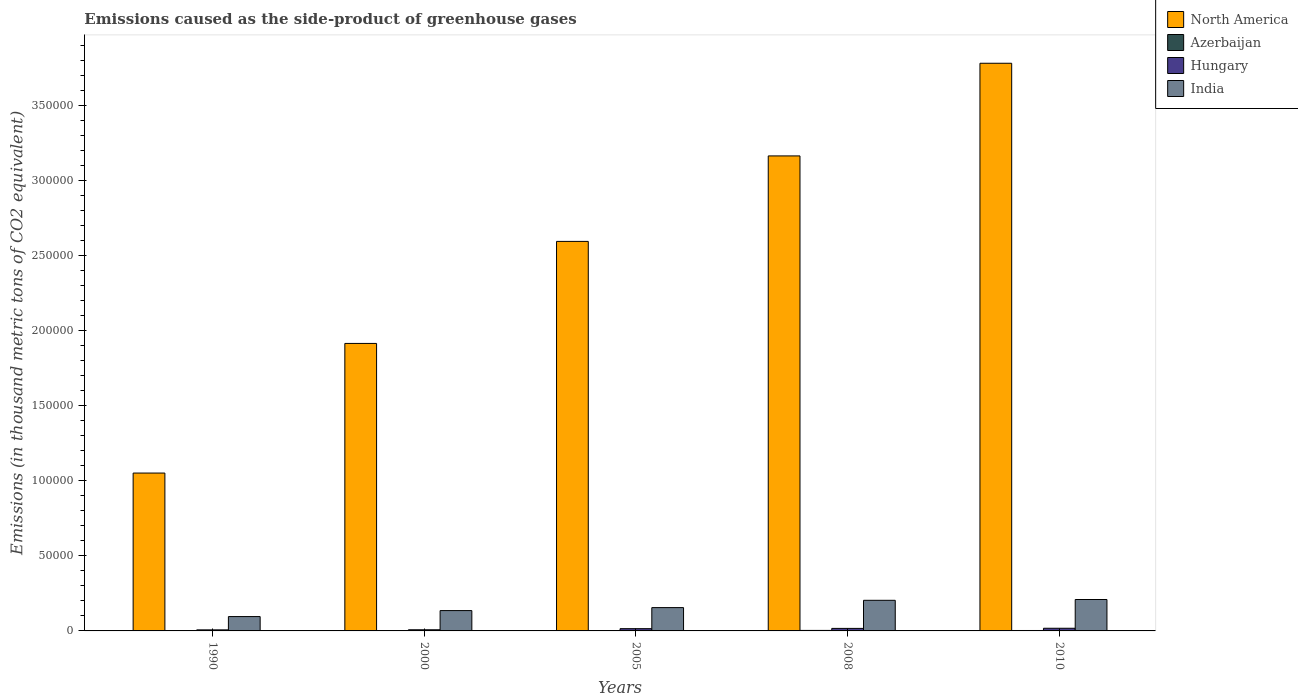How many different coloured bars are there?
Provide a succinct answer. 4. How many bars are there on the 4th tick from the right?
Your answer should be very brief. 4. What is the label of the 4th group of bars from the left?
Provide a succinct answer. 2008. What is the emissions caused as the side-product of greenhouse gases in India in 1990?
Make the answer very short. 9563.6. Across all years, what is the maximum emissions caused as the side-product of greenhouse gases in Hungary?
Offer a terse response. 1778. Across all years, what is the minimum emissions caused as the side-product of greenhouse gases in North America?
Keep it short and to the point. 1.05e+05. What is the total emissions caused as the side-product of greenhouse gases in Hungary in the graph?
Make the answer very short. 6431.5. What is the difference between the emissions caused as the side-product of greenhouse gases in Hungary in 2000 and that in 2005?
Your answer should be compact. -743.2. What is the difference between the emissions caused as the side-product of greenhouse gases in Azerbaijan in 2008 and the emissions caused as the side-product of greenhouse gases in Hungary in 2010?
Your answer should be very brief. -1442.7. What is the average emissions caused as the side-product of greenhouse gases in Hungary per year?
Provide a succinct answer. 1286.3. In the year 2005, what is the difference between the emissions caused as the side-product of greenhouse gases in Azerbaijan and emissions caused as the side-product of greenhouse gases in Hungary?
Provide a succinct answer. -1240. What is the ratio of the emissions caused as the side-product of greenhouse gases in North America in 2005 to that in 2008?
Ensure brevity in your answer.  0.82. What is the difference between the highest and the second highest emissions caused as the side-product of greenhouse gases in Azerbaijan?
Ensure brevity in your answer.  52.3. What is the difference between the highest and the lowest emissions caused as the side-product of greenhouse gases in Hungary?
Offer a terse response. 1076. Is the sum of the emissions caused as the side-product of greenhouse gases in North America in 1990 and 2008 greater than the maximum emissions caused as the side-product of greenhouse gases in Hungary across all years?
Give a very brief answer. Yes. Is it the case that in every year, the sum of the emissions caused as the side-product of greenhouse gases in India and emissions caused as the side-product of greenhouse gases in Hungary is greater than the sum of emissions caused as the side-product of greenhouse gases in North America and emissions caused as the side-product of greenhouse gases in Azerbaijan?
Provide a short and direct response. Yes. What does the 4th bar from the left in 2000 represents?
Your answer should be compact. India. Are all the bars in the graph horizontal?
Your response must be concise. No. How many years are there in the graph?
Ensure brevity in your answer.  5. Does the graph contain grids?
Your answer should be compact. No. How are the legend labels stacked?
Make the answer very short. Vertical. What is the title of the graph?
Provide a succinct answer. Emissions caused as the side-product of greenhouse gases. Does "Denmark" appear as one of the legend labels in the graph?
Make the answer very short. No. What is the label or title of the Y-axis?
Your answer should be compact. Emissions (in thousand metric tons of CO2 equivalent). What is the Emissions (in thousand metric tons of CO2 equivalent) in North America in 1990?
Provide a succinct answer. 1.05e+05. What is the Emissions (in thousand metric tons of CO2 equivalent) in Azerbaijan in 1990?
Your answer should be very brief. 175.6. What is the Emissions (in thousand metric tons of CO2 equivalent) in Hungary in 1990?
Ensure brevity in your answer.  702. What is the Emissions (in thousand metric tons of CO2 equivalent) of India in 1990?
Ensure brevity in your answer.  9563.6. What is the Emissions (in thousand metric tons of CO2 equivalent) of North America in 2000?
Provide a succinct answer. 1.92e+05. What is the Emissions (in thousand metric tons of CO2 equivalent) in Azerbaijan in 2000?
Offer a terse response. 41.3. What is the Emissions (in thousand metric tons of CO2 equivalent) in Hungary in 2000?
Provide a short and direct response. 761.9. What is the Emissions (in thousand metric tons of CO2 equivalent) in India in 2000?
Your response must be concise. 1.36e+04. What is the Emissions (in thousand metric tons of CO2 equivalent) of North America in 2005?
Make the answer very short. 2.60e+05. What is the Emissions (in thousand metric tons of CO2 equivalent) in Azerbaijan in 2005?
Keep it short and to the point. 265.1. What is the Emissions (in thousand metric tons of CO2 equivalent) of Hungary in 2005?
Give a very brief answer. 1505.1. What is the Emissions (in thousand metric tons of CO2 equivalent) in India in 2005?
Your answer should be very brief. 1.55e+04. What is the Emissions (in thousand metric tons of CO2 equivalent) in North America in 2008?
Provide a short and direct response. 3.17e+05. What is the Emissions (in thousand metric tons of CO2 equivalent) in Azerbaijan in 2008?
Your response must be concise. 335.3. What is the Emissions (in thousand metric tons of CO2 equivalent) in Hungary in 2008?
Keep it short and to the point. 1684.5. What is the Emissions (in thousand metric tons of CO2 equivalent) of India in 2008?
Your response must be concise. 2.04e+04. What is the Emissions (in thousand metric tons of CO2 equivalent) of North America in 2010?
Make the answer very short. 3.78e+05. What is the Emissions (in thousand metric tons of CO2 equivalent) in Azerbaijan in 2010?
Offer a terse response. 283. What is the Emissions (in thousand metric tons of CO2 equivalent) of Hungary in 2010?
Provide a succinct answer. 1778. What is the Emissions (in thousand metric tons of CO2 equivalent) in India in 2010?
Your response must be concise. 2.09e+04. Across all years, what is the maximum Emissions (in thousand metric tons of CO2 equivalent) in North America?
Offer a very short reply. 3.78e+05. Across all years, what is the maximum Emissions (in thousand metric tons of CO2 equivalent) in Azerbaijan?
Your answer should be compact. 335.3. Across all years, what is the maximum Emissions (in thousand metric tons of CO2 equivalent) in Hungary?
Give a very brief answer. 1778. Across all years, what is the maximum Emissions (in thousand metric tons of CO2 equivalent) of India?
Your answer should be very brief. 2.09e+04. Across all years, what is the minimum Emissions (in thousand metric tons of CO2 equivalent) in North America?
Your answer should be compact. 1.05e+05. Across all years, what is the minimum Emissions (in thousand metric tons of CO2 equivalent) of Azerbaijan?
Give a very brief answer. 41.3. Across all years, what is the minimum Emissions (in thousand metric tons of CO2 equivalent) of Hungary?
Ensure brevity in your answer.  702. Across all years, what is the minimum Emissions (in thousand metric tons of CO2 equivalent) in India?
Offer a very short reply. 9563.6. What is the total Emissions (in thousand metric tons of CO2 equivalent) in North America in the graph?
Your answer should be very brief. 1.25e+06. What is the total Emissions (in thousand metric tons of CO2 equivalent) in Azerbaijan in the graph?
Offer a terse response. 1100.3. What is the total Emissions (in thousand metric tons of CO2 equivalent) of Hungary in the graph?
Make the answer very short. 6431.5. What is the total Emissions (in thousand metric tons of CO2 equivalent) of India in the graph?
Ensure brevity in your answer.  8.00e+04. What is the difference between the Emissions (in thousand metric tons of CO2 equivalent) in North America in 1990 and that in 2000?
Your answer should be compact. -8.64e+04. What is the difference between the Emissions (in thousand metric tons of CO2 equivalent) in Azerbaijan in 1990 and that in 2000?
Give a very brief answer. 134.3. What is the difference between the Emissions (in thousand metric tons of CO2 equivalent) of Hungary in 1990 and that in 2000?
Offer a terse response. -59.9. What is the difference between the Emissions (in thousand metric tons of CO2 equivalent) of India in 1990 and that in 2000?
Offer a very short reply. -3987.1. What is the difference between the Emissions (in thousand metric tons of CO2 equivalent) in North America in 1990 and that in 2005?
Give a very brief answer. -1.54e+05. What is the difference between the Emissions (in thousand metric tons of CO2 equivalent) of Azerbaijan in 1990 and that in 2005?
Offer a terse response. -89.5. What is the difference between the Emissions (in thousand metric tons of CO2 equivalent) in Hungary in 1990 and that in 2005?
Offer a terse response. -803.1. What is the difference between the Emissions (in thousand metric tons of CO2 equivalent) of India in 1990 and that in 2005?
Your answer should be very brief. -5976.1. What is the difference between the Emissions (in thousand metric tons of CO2 equivalent) in North America in 1990 and that in 2008?
Your answer should be compact. -2.11e+05. What is the difference between the Emissions (in thousand metric tons of CO2 equivalent) in Azerbaijan in 1990 and that in 2008?
Offer a very short reply. -159.7. What is the difference between the Emissions (in thousand metric tons of CO2 equivalent) in Hungary in 1990 and that in 2008?
Provide a succinct answer. -982.5. What is the difference between the Emissions (in thousand metric tons of CO2 equivalent) of India in 1990 and that in 2008?
Give a very brief answer. -1.08e+04. What is the difference between the Emissions (in thousand metric tons of CO2 equivalent) of North America in 1990 and that in 2010?
Ensure brevity in your answer.  -2.73e+05. What is the difference between the Emissions (in thousand metric tons of CO2 equivalent) of Azerbaijan in 1990 and that in 2010?
Offer a very short reply. -107.4. What is the difference between the Emissions (in thousand metric tons of CO2 equivalent) in Hungary in 1990 and that in 2010?
Make the answer very short. -1076. What is the difference between the Emissions (in thousand metric tons of CO2 equivalent) of India in 1990 and that in 2010?
Provide a succinct answer. -1.14e+04. What is the difference between the Emissions (in thousand metric tons of CO2 equivalent) of North America in 2000 and that in 2005?
Give a very brief answer. -6.80e+04. What is the difference between the Emissions (in thousand metric tons of CO2 equivalent) of Azerbaijan in 2000 and that in 2005?
Provide a succinct answer. -223.8. What is the difference between the Emissions (in thousand metric tons of CO2 equivalent) in Hungary in 2000 and that in 2005?
Provide a short and direct response. -743.2. What is the difference between the Emissions (in thousand metric tons of CO2 equivalent) of India in 2000 and that in 2005?
Provide a short and direct response. -1989. What is the difference between the Emissions (in thousand metric tons of CO2 equivalent) of North America in 2000 and that in 2008?
Make the answer very short. -1.25e+05. What is the difference between the Emissions (in thousand metric tons of CO2 equivalent) of Azerbaijan in 2000 and that in 2008?
Make the answer very short. -294. What is the difference between the Emissions (in thousand metric tons of CO2 equivalent) of Hungary in 2000 and that in 2008?
Your answer should be compact. -922.6. What is the difference between the Emissions (in thousand metric tons of CO2 equivalent) in India in 2000 and that in 2008?
Offer a terse response. -6856.2. What is the difference between the Emissions (in thousand metric tons of CO2 equivalent) in North America in 2000 and that in 2010?
Your answer should be very brief. -1.87e+05. What is the difference between the Emissions (in thousand metric tons of CO2 equivalent) in Azerbaijan in 2000 and that in 2010?
Your answer should be compact. -241.7. What is the difference between the Emissions (in thousand metric tons of CO2 equivalent) in Hungary in 2000 and that in 2010?
Make the answer very short. -1016.1. What is the difference between the Emissions (in thousand metric tons of CO2 equivalent) of India in 2000 and that in 2010?
Keep it short and to the point. -7386.3. What is the difference between the Emissions (in thousand metric tons of CO2 equivalent) of North America in 2005 and that in 2008?
Provide a short and direct response. -5.70e+04. What is the difference between the Emissions (in thousand metric tons of CO2 equivalent) of Azerbaijan in 2005 and that in 2008?
Keep it short and to the point. -70.2. What is the difference between the Emissions (in thousand metric tons of CO2 equivalent) of Hungary in 2005 and that in 2008?
Your answer should be compact. -179.4. What is the difference between the Emissions (in thousand metric tons of CO2 equivalent) of India in 2005 and that in 2008?
Keep it short and to the point. -4867.2. What is the difference between the Emissions (in thousand metric tons of CO2 equivalent) of North America in 2005 and that in 2010?
Provide a short and direct response. -1.19e+05. What is the difference between the Emissions (in thousand metric tons of CO2 equivalent) of Azerbaijan in 2005 and that in 2010?
Your answer should be very brief. -17.9. What is the difference between the Emissions (in thousand metric tons of CO2 equivalent) in Hungary in 2005 and that in 2010?
Provide a short and direct response. -272.9. What is the difference between the Emissions (in thousand metric tons of CO2 equivalent) in India in 2005 and that in 2010?
Offer a terse response. -5397.3. What is the difference between the Emissions (in thousand metric tons of CO2 equivalent) of North America in 2008 and that in 2010?
Keep it short and to the point. -6.17e+04. What is the difference between the Emissions (in thousand metric tons of CO2 equivalent) of Azerbaijan in 2008 and that in 2010?
Ensure brevity in your answer.  52.3. What is the difference between the Emissions (in thousand metric tons of CO2 equivalent) of Hungary in 2008 and that in 2010?
Offer a very short reply. -93.5. What is the difference between the Emissions (in thousand metric tons of CO2 equivalent) of India in 2008 and that in 2010?
Give a very brief answer. -530.1. What is the difference between the Emissions (in thousand metric tons of CO2 equivalent) in North America in 1990 and the Emissions (in thousand metric tons of CO2 equivalent) in Azerbaijan in 2000?
Your response must be concise. 1.05e+05. What is the difference between the Emissions (in thousand metric tons of CO2 equivalent) of North America in 1990 and the Emissions (in thousand metric tons of CO2 equivalent) of Hungary in 2000?
Your answer should be compact. 1.04e+05. What is the difference between the Emissions (in thousand metric tons of CO2 equivalent) of North America in 1990 and the Emissions (in thousand metric tons of CO2 equivalent) of India in 2000?
Keep it short and to the point. 9.16e+04. What is the difference between the Emissions (in thousand metric tons of CO2 equivalent) of Azerbaijan in 1990 and the Emissions (in thousand metric tons of CO2 equivalent) of Hungary in 2000?
Your answer should be compact. -586.3. What is the difference between the Emissions (in thousand metric tons of CO2 equivalent) of Azerbaijan in 1990 and the Emissions (in thousand metric tons of CO2 equivalent) of India in 2000?
Offer a terse response. -1.34e+04. What is the difference between the Emissions (in thousand metric tons of CO2 equivalent) in Hungary in 1990 and the Emissions (in thousand metric tons of CO2 equivalent) in India in 2000?
Offer a very short reply. -1.28e+04. What is the difference between the Emissions (in thousand metric tons of CO2 equivalent) in North America in 1990 and the Emissions (in thousand metric tons of CO2 equivalent) in Azerbaijan in 2005?
Ensure brevity in your answer.  1.05e+05. What is the difference between the Emissions (in thousand metric tons of CO2 equivalent) in North America in 1990 and the Emissions (in thousand metric tons of CO2 equivalent) in Hungary in 2005?
Keep it short and to the point. 1.04e+05. What is the difference between the Emissions (in thousand metric tons of CO2 equivalent) of North America in 1990 and the Emissions (in thousand metric tons of CO2 equivalent) of India in 2005?
Ensure brevity in your answer.  8.97e+04. What is the difference between the Emissions (in thousand metric tons of CO2 equivalent) in Azerbaijan in 1990 and the Emissions (in thousand metric tons of CO2 equivalent) in Hungary in 2005?
Keep it short and to the point. -1329.5. What is the difference between the Emissions (in thousand metric tons of CO2 equivalent) in Azerbaijan in 1990 and the Emissions (in thousand metric tons of CO2 equivalent) in India in 2005?
Your response must be concise. -1.54e+04. What is the difference between the Emissions (in thousand metric tons of CO2 equivalent) of Hungary in 1990 and the Emissions (in thousand metric tons of CO2 equivalent) of India in 2005?
Make the answer very short. -1.48e+04. What is the difference between the Emissions (in thousand metric tons of CO2 equivalent) in North America in 1990 and the Emissions (in thousand metric tons of CO2 equivalent) in Azerbaijan in 2008?
Give a very brief answer. 1.05e+05. What is the difference between the Emissions (in thousand metric tons of CO2 equivalent) in North America in 1990 and the Emissions (in thousand metric tons of CO2 equivalent) in Hungary in 2008?
Your answer should be very brief. 1.04e+05. What is the difference between the Emissions (in thousand metric tons of CO2 equivalent) of North America in 1990 and the Emissions (in thousand metric tons of CO2 equivalent) of India in 2008?
Your answer should be compact. 8.48e+04. What is the difference between the Emissions (in thousand metric tons of CO2 equivalent) of Azerbaijan in 1990 and the Emissions (in thousand metric tons of CO2 equivalent) of Hungary in 2008?
Keep it short and to the point. -1508.9. What is the difference between the Emissions (in thousand metric tons of CO2 equivalent) in Azerbaijan in 1990 and the Emissions (in thousand metric tons of CO2 equivalent) in India in 2008?
Provide a succinct answer. -2.02e+04. What is the difference between the Emissions (in thousand metric tons of CO2 equivalent) in Hungary in 1990 and the Emissions (in thousand metric tons of CO2 equivalent) in India in 2008?
Your answer should be compact. -1.97e+04. What is the difference between the Emissions (in thousand metric tons of CO2 equivalent) in North America in 1990 and the Emissions (in thousand metric tons of CO2 equivalent) in Azerbaijan in 2010?
Provide a succinct answer. 1.05e+05. What is the difference between the Emissions (in thousand metric tons of CO2 equivalent) in North America in 1990 and the Emissions (in thousand metric tons of CO2 equivalent) in Hungary in 2010?
Your answer should be very brief. 1.03e+05. What is the difference between the Emissions (in thousand metric tons of CO2 equivalent) in North America in 1990 and the Emissions (in thousand metric tons of CO2 equivalent) in India in 2010?
Make the answer very short. 8.43e+04. What is the difference between the Emissions (in thousand metric tons of CO2 equivalent) of Azerbaijan in 1990 and the Emissions (in thousand metric tons of CO2 equivalent) of Hungary in 2010?
Keep it short and to the point. -1602.4. What is the difference between the Emissions (in thousand metric tons of CO2 equivalent) of Azerbaijan in 1990 and the Emissions (in thousand metric tons of CO2 equivalent) of India in 2010?
Your answer should be very brief. -2.08e+04. What is the difference between the Emissions (in thousand metric tons of CO2 equivalent) of Hungary in 1990 and the Emissions (in thousand metric tons of CO2 equivalent) of India in 2010?
Ensure brevity in your answer.  -2.02e+04. What is the difference between the Emissions (in thousand metric tons of CO2 equivalent) in North America in 2000 and the Emissions (in thousand metric tons of CO2 equivalent) in Azerbaijan in 2005?
Keep it short and to the point. 1.91e+05. What is the difference between the Emissions (in thousand metric tons of CO2 equivalent) in North America in 2000 and the Emissions (in thousand metric tons of CO2 equivalent) in Hungary in 2005?
Offer a very short reply. 1.90e+05. What is the difference between the Emissions (in thousand metric tons of CO2 equivalent) in North America in 2000 and the Emissions (in thousand metric tons of CO2 equivalent) in India in 2005?
Your answer should be compact. 1.76e+05. What is the difference between the Emissions (in thousand metric tons of CO2 equivalent) in Azerbaijan in 2000 and the Emissions (in thousand metric tons of CO2 equivalent) in Hungary in 2005?
Your answer should be very brief. -1463.8. What is the difference between the Emissions (in thousand metric tons of CO2 equivalent) of Azerbaijan in 2000 and the Emissions (in thousand metric tons of CO2 equivalent) of India in 2005?
Give a very brief answer. -1.55e+04. What is the difference between the Emissions (in thousand metric tons of CO2 equivalent) of Hungary in 2000 and the Emissions (in thousand metric tons of CO2 equivalent) of India in 2005?
Your response must be concise. -1.48e+04. What is the difference between the Emissions (in thousand metric tons of CO2 equivalent) in North America in 2000 and the Emissions (in thousand metric tons of CO2 equivalent) in Azerbaijan in 2008?
Ensure brevity in your answer.  1.91e+05. What is the difference between the Emissions (in thousand metric tons of CO2 equivalent) of North America in 2000 and the Emissions (in thousand metric tons of CO2 equivalent) of Hungary in 2008?
Provide a short and direct response. 1.90e+05. What is the difference between the Emissions (in thousand metric tons of CO2 equivalent) of North America in 2000 and the Emissions (in thousand metric tons of CO2 equivalent) of India in 2008?
Your answer should be compact. 1.71e+05. What is the difference between the Emissions (in thousand metric tons of CO2 equivalent) in Azerbaijan in 2000 and the Emissions (in thousand metric tons of CO2 equivalent) in Hungary in 2008?
Offer a terse response. -1643.2. What is the difference between the Emissions (in thousand metric tons of CO2 equivalent) in Azerbaijan in 2000 and the Emissions (in thousand metric tons of CO2 equivalent) in India in 2008?
Give a very brief answer. -2.04e+04. What is the difference between the Emissions (in thousand metric tons of CO2 equivalent) in Hungary in 2000 and the Emissions (in thousand metric tons of CO2 equivalent) in India in 2008?
Give a very brief answer. -1.96e+04. What is the difference between the Emissions (in thousand metric tons of CO2 equivalent) of North America in 2000 and the Emissions (in thousand metric tons of CO2 equivalent) of Azerbaijan in 2010?
Offer a very short reply. 1.91e+05. What is the difference between the Emissions (in thousand metric tons of CO2 equivalent) of North America in 2000 and the Emissions (in thousand metric tons of CO2 equivalent) of Hungary in 2010?
Your response must be concise. 1.90e+05. What is the difference between the Emissions (in thousand metric tons of CO2 equivalent) in North America in 2000 and the Emissions (in thousand metric tons of CO2 equivalent) in India in 2010?
Provide a succinct answer. 1.71e+05. What is the difference between the Emissions (in thousand metric tons of CO2 equivalent) of Azerbaijan in 2000 and the Emissions (in thousand metric tons of CO2 equivalent) of Hungary in 2010?
Keep it short and to the point. -1736.7. What is the difference between the Emissions (in thousand metric tons of CO2 equivalent) of Azerbaijan in 2000 and the Emissions (in thousand metric tons of CO2 equivalent) of India in 2010?
Your answer should be compact. -2.09e+04. What is the difference between the Emissions (in thousand metric tons of CO2 equivalent) of Hungary in 2000 and the Emissions (in thousand metric tons of CO2 equivalent) of India in 2010?
Give a very brief answer. -2.02e+04. What is the difference between the Emissions (in thousand metric tons of CO2 equivalent) of North America in 2005 and the Emissions (in thousand metric tons of CO2 equivalent) of Azerbaijan in 2008?
Give a very brief answer. 2.59e+05. What is the difference between the Emissions (in thousand metric tons of CO2 equivalent) in North America in 2005 and the Emissions (in thousand metric tons of CO2 equivalent) in Hungary in 2008?
Provide a short and direct response. 2.58e+05. What is the difference between the Emissions (in thousand metric tons of CO2 equivalent) of North America in 2005 and the Emissions (in thousand metric tons of CO2 equivalent) of India in 2008?
Give a very brief answer. 2.39e+05. What is the difference between the Emissions (in thousand metric tons of CO2 equivalent) of Azerbaijan in 2005 and the Emissions (in thousand metric tons of CO2 equivalent) of Hungary in 2008?
Give a very brief answer. -1419.4. What is the difference between the Emissions (in thousand metric tons of CO2 equivalent) of Azerbaijan in 2005 and the Emissions (in thousand metric tons of CO2 equivalent) of India in 2008?
Your response must be concise. -2.01e+04. What is the difference between the Emissions (in thousand metric tons of CO2 equivalent) in Hungary in 2005 and the Emissions (in thousand metric tons of CO2 equivalent) in India in 2008?
Your answer should be compact. -1.89e+04. What is the difference between the Emissions (in thousand metric tons of CO2 equivalent) in North America in 2005 and the Emissions (in thousand metric tons of CO2 equivalent) in Azerbaijan in 2010?
Your response must be concise. 2.59e+05. What is the difference between the Emissions (in thousand metric tons of CO2 equivalent) of North America in 2005 and the Emissions (in thousand metric tons of CO2 equivalent) of Hungary in 2010?
Your answer should be compact. 2.58e+05. What is the difference between the Emissions (in thousand metric tons of CO2 equivalent) in North America in 2005 and the Emissions (in thousand metric tons of CO2 equivalent) in India in 2010?
Your answer should be compact. 2.39e+05. What is the difference between the Emissions (in thousand metric tons of CO2 equivalent) in Azerbaijan in 2005 and the Emissions (in thousand metric tons of CO2 equivalent) in Hungary in 2010?
Make the answer very short. -1512.9. What is the difference between the Emissions (in thousand metric tons of CO2 equivalent) of Azerbaijan in 2005 and the Emissions (in thousand metric tons of CO2 equivalent) of India in 2010?
Keep it short and to the point. -2.07e+04. What is the difference between the Emissions (in thousand metric tons of CO2 equivalent) in Hungary in 2005 and the Emissions (in thousand metric tons of CO2 equivalent) in India in 2010?
Your answer should be very brief. -1.94e+04. What is the difference between the Emissions (in thousand metric tons of CO2 equivalent) in North America in 2008 and the Emissions (in thousand metric tons of CO2 equivalent) in Azerbaijan in 2010?
Your response must be concise. 3.16e+05. What is the difference between the Emissions (in thousand metric tons of CO2 equivalent) in North America in 2008 and the Emissions (in thousand metric tons of CO2 equivalent) in Hungary in 2010?
Provide a succinct answer. 3.15e+05. What is the difference between the Emissions (in thousand metric tons of CO2 equivalent) in North America in 2008 and the Emissions (in thousand metric tons of CO2 equivalent) in India in 2010?
Provide a succinct answer. 2.96e+05. What is the difference between the Emissions (in thousand metric tons of CO2 equivalent) of Azerbaijan in 2008 and the Emissions (in thousand metric tons of CO2 equivalent) of Hungary in 2010?
Ensure brevity in your answer.  -1442.7. What is the difference between the Emissions (in thousand metric tons of CO2 equivalent) of Azerbaijan in 2008 and the Emissions (in thousand metric tons of CO2 equivalent) of India in 2010?
Give a very brief answer. -2.06e+04. What is the difference between the Emissions (in thousand metric tons of CO2 equivalent) of Hungary in 2008 and the Emissions (in thousand metric tons of CO2 equivalent) of India in 2010?
Make the answer very short. -1.93e+04. What is the average Emissions (in thousand metric tons of CO2 equivalent) in North America per year?
Offer a terse response. 2.50e+05. What is the average Emissions (in thousand metric tons of CO2 equivalent) in Azerbaijan per year?
Give a very brief answer. 220.06. What is the average Emissions (in thousand metric tons of CO2 equivalent) in Hungary per year?
Give a very brief answer. 1286.3. What is the average Emissions (in thousand metric tons of CO2 equivalent) in India per year?
Your answer should be compact. 1.60e+04. In the year 1990, what is the difference between the Emissions (in thousand metric tons of CO2 equivalent) in North America and Emissions (in thousand metric tons of CO2 equivalent) in Azerbaijan?
Your answer should be very brief. 1.05e+05. In the year 1990, what is the difference between the Emissions (in thousand metric tons of CO2 equivalent) in North America and Emissions (in thousand metric tons of CO2 equivalent) in Hungary?
Offer a terse response. 1.04e+05. In the year 1990, what is the difference between the Emissions (in thousand metric tons of CO2 equivalent) of North America and Emissions (in thousand metric tons of CO2 equivalent) of India?
Offer a terse response. 9.56e+04. In the year 1990, what is the difference between the Emissions (in thousand metric tons of CO2 equivalent) of Azerbaijan and Emissions (in thousand metric tons of CO2 equivalent) of Hungary?
Your response must be concise. -526.4. In the year 1990, what is the difference between the Emissions (in thousand metric tons of CO2 equivalent) of Azerbaijan and Emissions (in thousand metric tons of CO2 equivalent) of India?
Offer a very short reply. -9388. In the year 1990, what is the difference between the Emissions (in thousand metric tons of CO2 equivalent) of Hungary and Emissions (in thousand metric tons of CO2 equivalent) of India?
Make the answer very short. -8861.6. In the year 2000, what is the difference between the Emissions (in thousand metric tons of CO2 equivalent) of North America and Emissions (in thousand metric tons of CO2 equivalent) of Azerbaijan?
Offer a very short reply. 1.92e+05. In the year 2000, what is the difference between the Emissions (in thousand metric tons of CO2 equivalent) in North America and Emissions (in thousand metric tons of CO2 equivalent) in Hungary?
Offer a very short reply. 1.91e+05. In the year 2000, what is the difference between the Emissions (in thousand metric tons of CO2 equivalent) in North America and Emissions (in thousand metric tons of CO2 equivalent) in India?
Provide a short and direct response. 1.78e+05. In the year 2000, what is the difference between the Emissions (in thousand metric tons of CO2 equivalent) in Azerbaijan and Emissions (in thousand metric tons of CO2 equivalent) in Hungary?
Ensure brevity in your answer.  -720.6. In the year 2000, what is the difference between the Emissions (in thousand metric tons of CO2 equivalent) of Azerbaijan and Emissions (in thousand metric tons of CO2 equivalent) of India?
Offer a terse response. -1.35e+04. In the year 2000, what is the difference between the Emissions (in thousand metric tons of CO2 equivalent) of Hungary and Emissions (in thousand metric tons of CO2 equivalent) of India?
Offer a very short reply. -1.28e+04. In the year 2005, what is the difference between the Emissions (in thousand metric tons of CO2 equivalent) in North America and Emissions (in thousand metric tons of CO2 equivalent) in Azerbaijan?
Provide a short and direct response. 2.59e+05. In the year 2005, what is the difference between the Emissions (in thousand metric tons of CO2 equivalent) in North America and Emissions (in thousand metric tons of CO2 equivalent) in Hungary?
Offer a very short reply. 2.58e+05. In the year 2005, what is the difference between the Emissions (in thousand metric tons of CO2 equivalent) in North America and Emissions (in thousand metric tons of CO2 equivalent) in India?
Your response must be concise. 2.44e+05. In the year 2005, what is the difference between the Emissions (in thousand metric tons of CO2 equivalent) in Azerbaijan and Emissions (in thousand metric tons of CO2 equivalent) in Hungary?
Make the answer very short. -1240. In the year 2005, what is the difference between the Emissions (in thousand metric tons of CO2 equivalent) in Azerbaijan and Emissions (in thousand metric tons of CO2 equivalent) in India?
Provide a short and direct response. -1.53e+04. In the year 2005, what is the difference between the Emissions (in thousand metric tons of CO2 equivalent) in Hungary and Emissions (in thousand metric tons of CO2 equivalent) in India?
Make the answer very short. -1.40e+04. In the year 2008, what is the difference between the Emissions (in thousand metric tons of CO2 equivalent) in North America and Emissions (in thousand metric tons of CO2 equivalent) in Azerbaijan?
Make the answer very short. 3.16e+05. In the year 2008, what is the difference between the Emissions (in thousand metric tons of CO2 equivalent) in North America and Emissions (in thousand metric tons of CO2 equivalent) in Hungary?
Keep it short and to the point. 3.15e+05. In the year 2008, what is the difference between the Emissions (in thousand metric tons of CO2 equivalent) in North America and Emissions (in thousand metric tons of CO2 equivalent) in India?
Give a very brief answer. 2.96e+05. In the year 2008, what is the difference between the Emissions (in thousand metric tons of CO2 equivalent) in Azerbaijan and Emissions (in thousand metric tons of CO2 equivalent) in Hungary?
Give a very brief answer. -1349.2. In the year 2008, what is the difference between the Emissions (in thousand metric tons of CO2 equivalent) in Azerbaijan and Emissions (in thousand metric tons of CO2 equivalent) in India?
Offer a very short reply. -2.01e+04. In the year 2008, what is the difference between the Emissions (in thousand metric tons of CO2 equivalent) in Hungary and Emissions (in thousand metric tons of CO2 equivalent) in India?
Provide a succinct answer. -1.87e+04. In the year 2010, what is the difference between the Emissions (in thousand metric tons of CO2 equivalent) in North America and Emissions (in thousand metric tons of CO2 equivalent) in Azerbaijan?
Your response must be concise. 3.78e+05. In the year 2010, what is the difference between the Emissions (in thousand metric tons of CO2 equivalent) in North America and Emissions (in thousand metric tons of CO2 equivalent) in Hungary?
Your response must be concise. 3.77e+05. In the year 2010, what is the difference between the Emissions (in thousand metric tons of CO2 equivalent) of North America and Emissions (in thousand metric tons of CO2 equivalent) of India?
Offer a very short reply. 3.57e+05. In the year 2010, what is the difference between the Emissions (in thousand metric tons of CO2 equivalent) of Azerbaijan and Emissions (in thousand metric tons of CO2 equivalent) of Hungary?
Keep it short and to the point. -1495. In the year 2010, what is the difference between the Emissions (in thousand metric tons of CO2 equivalent) of Azerbaijan and Emissions (in thousand metric tons of CO2 equivalent) of India?
Ensure brevity in your answer.  -2.07e+04. In the year 2010, what is the difference between the Emissions (in thousand metric tons of CO2 equivalent) of Hungary and Emissions (in thousand metric tons of CO2 equivalent) of India?
Your answer should be very brief. -1.92e+04. What is the ratio of the Emissions (in thousand metric tons of CO2 equivalent) in North America in 1990 to that in 2000?
Give a very brief answer. 0.55. What is the ratio of the Emissions (in thousand metric tons of CO2 equivalent) in Azerbaijan in 1990 to that in 2000?
Ensure brevity in your answer.  4.25. What is the ratio of the Emissions (in thousand metric tons of CO2 equivalent) in Hungary in 1990 to that in 2000?
Provide a succinct answer. 0.92. What is the ratio of the Emissions (in thousand metric tons of CO2 equivalent) of India in 1990 to that in 2000?
Offer a terse response. 0.71. What is the ratio of the Emissions (in thousand metric tons of CO2 equivalent) of North America in 1990 to that in 2005?
Your answer should be very brief. 0.41. What is the ratio of the Emissions (in thousand metric tons of CO2 equivalent) in Azerbaijan in 1990 to that in 2005?
Provide a short and direct response. 0.66. What is the ratio of the Emissions (in thousand metric tons of CO2 equivalent) in Hungary in 1990 to that in 2005?
Your answer should be compact. 0.47. What is the ratio of the Emissions (in thousand metric tons of CO2 equivalent) of India in 1990 to that in 2005?
Offer a terse response. 0.62. What is the ratio of the Emissions (in thousand metric tons of CO2 equivalent) of North America in 1990 to that in 2008?
Your answer should be very brief. 0.33. What is the ratio of the Emissions (in thousand metric tons of CO2 equivalent) of Azerbaijan in 1990 to that in 2008?
Your answer should be compact. 0.52. What is the ratio of the Emissions (in thousand metric tons of CO2 equivalent) of Hungary in 1990 to that in 2008?
Offer a terse response. 0.42. What is the ratio of the Emissions (in thousand metric tons of CO2 equivalent) in India in 1990 to that in 2008?
Your answer should be compact. 0.47. What is the ratio of the Emissions (in thousand metric tons of CO2 equivalent) in North America in 1990 to that in 2010?
Your answer should be compact. 0.28. What is the ratio of the Emissions (in thousand metric tons of CO2 equivalent) in Azerbaijan in 1990 to that in 2010?
Ensure brevity in your answer.  0.62. What is the ratio of the Emissions (in thousand metric tons of CO2 equivalent) of Hungary in 1990 to that in 2010?
Offer a very short reply. 0.39. What is the ratio of the Emissions (in thousand metric tons of CO2 equivalent) in India in 1990 to that in 2010?
Make the answer very short. 0.46. What is the ratio of the Emissions (in thousand metric tons of CO2 equivalent) of North America in 2000 to that in 2005?
Your answer should be compact. 0.74. What is the ratio of the Emissions (in thousand metric tons of CO2 equivalent) in Azerbaijan in 2000 to that in 2005?
Make the answer very short. 0.16. What is the ratio of the Emissions (in thousand metric tons of CO2 equivalent) of Hungary in 2000 to that in 2005?
Provide a short and direct response. 0.51. What is the ratio of the Emissions (in thousand metric tons of CO2 equivalent) in India in 2000 to that in 2005?
Make the answer very short. 0.87. What is the ratio of the Emissions (in thousand metric tons of CO2 equivalent) in North America in 2000 to that in 2008?
Keep it short and to the point. 0.61. What is the ratio of the Emissions (in thousand metric tons of CO2 equivalent) of Azerbaijan in 2000 to that in 2008?
Give a very brief answer. 0.12. What is the ratio of the Emissions (in thousand metric tons of CO2 equivalent) in Hungary in 2000 to that in 2008?
Offer a very short reply. 0.45. What is the ratio of the Emissions (in thousand metric tons of CO2 equivalent) in India in 2000 to that in 2008?
Make the answer very short. 0.66. What is the ratio of the Emissions (in thousand metric tons of CO2 equivalent) in North America in 2000 to that in 2010?
Provide a short and direct response. 0.51. What is the ratio of the Emissions (in thousand metric tons of CO2 equivalent) in Azerbaijan in 2000 to that in 2010?
Offer a terse response. 0.15. What is the ratio of the Emissions (in thousand metric tons of CO2 equivalent) of Hungary in 2000 to that in 2010?
Provide a short and direct response. 0.43. What is the ratio of the Emissions (in thousand metric tons of CO2 equivalent) of India in 2000 to that in 2010?
Give a very brief answer. 0.65. What is the ratio of the Emissions (in thousand metric tons of CO2 equivalent) of North America in 2005 to that in 2008?
Your answer should be compact. 0.82. What is the ratio of the Emissions (in thousand metric tons of CO2 equivalent) in Azerbaijan in 2005 to that in 2008?
Provide a short and direct response. 0.79. What is the ratio of the Emissions (in thousand metric tons of CO2 equivalent) in Hungary in 2005 to that in 2008?
Your answer should be very brief. 0.89. What is the ratio of the Emissions (in thousand metric tons of CO2 equivalent) in India in 2005 to that in 2008?
Offer a terse response. 0.76. What is the ratio of the Emissions (in thousand metric tons of CO2 equivalent) of North America in 2005 to that in 2010?
Your answer should be very brief. 0.69. What is the ratio of the Emissions (in thousand metric tons of CO2 equivalent) of Azerbaijan in 2005 to that in 2010?
Your response must be concise. 0.94. What is the ratio of the Emissions (in thousand metric tons of CO2 equivalent) in Hungary in 2005 to that in 2010?
Your answer should be very brief. 0.85. What is the ratio of the Emissions (in thousand metric tons of CO2 equivalent) of India in 2005 to that in 2010?
Your answer should be very brief. 0.74. What is the ratio of the Emissions (in thousand metric tons of CO2 equivalent) of North America in 2008 to that in 2010?
Offer a very short reply. 0.84. What is the ratio of the Emissions (in thousand metric tons of CO2 equivalent) of Azerbaijan in 2008 to that in 2010?
Provide a short and direct response. 1.18. What is the ratio of the Emissions (in thousand metric tons of CO2 equivalent) of Hungary in 2008 to that in 2010?
Ensure brevity in your answer.  0.95. What is the ratio of the Emissions (in thousand metric tons of CO2 equivalent) in India in 2008 to that in 2010?
Ensure brevity in your answer.  0.97. What is the difference between the highest and the second highest Emissions (in thousand metric tons of CO2 equivalent) in North America?
Provide a succinct answer. 6.17e+04. What is the difference between the highest and the second highest Emissions (in thousand metric tons of CO2 equivalent) in Azerbaijan?
Make the answer very short. 52.3. What is the difference between the highest and the second highest Emissions (in thousand metric tons of CO2 equivalent) in Hungary?
Make the answer very short. 93.5. What is the difference between the highest and the second highest Emissions (in thousand metric tons of CO2 equivalent) in India?
Keep it short and to the point. 530.1. What is the difference between the highest and the lowest Emissions (in thousand metric tons of CO2 equivalent) in North America?
Your response must be concise. 2.73e+05. What is the difference between the highest and the lowest Emissions (in thousand metric tons of CO2 equivalent) in Azerbaijan?
Ensure brevity in your answer.  294. What is the difference between the highest and the lowest Emissions (in thousand metric tons of CO2 equivalent) of Hungary?
Give a very brief answer. 1076. What is the difference between the highest and the lowest Emissions (in thousand metric tons of CO2 equivalent) in India?
Your answer should be very brief. 1.14e+04. 